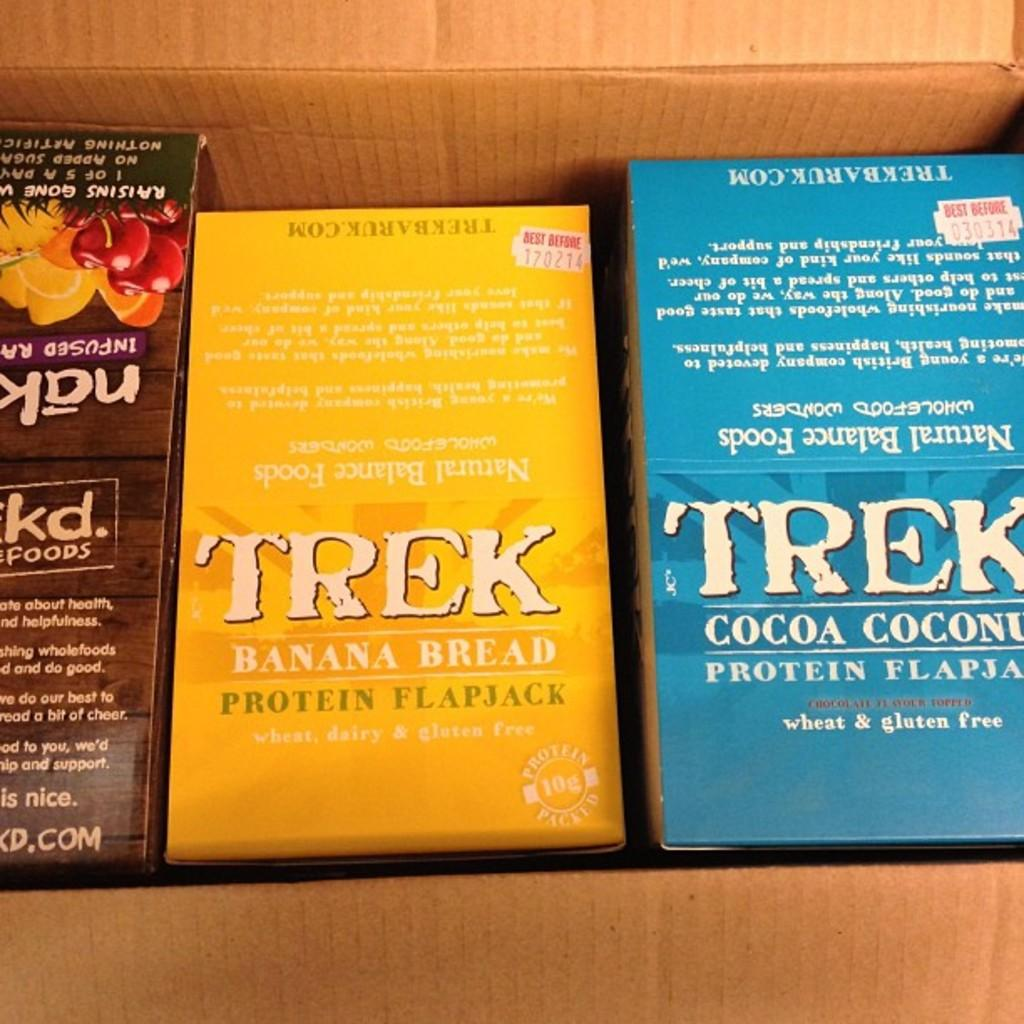<image>
Present a compact description of the photo's key features. Trek brand banana bread says that it has protein in it. 